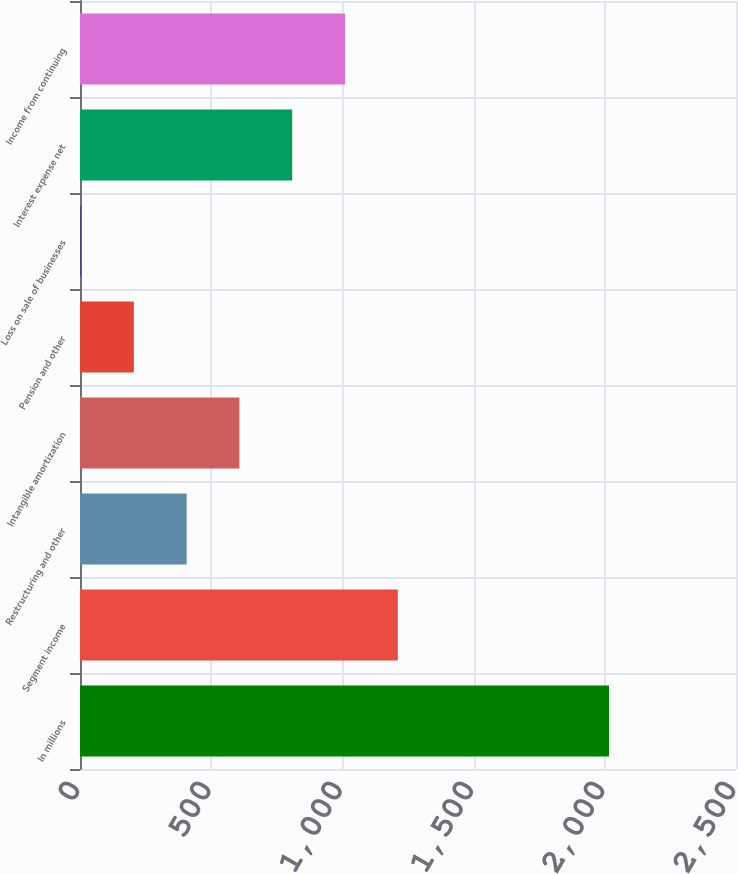Convert chart to OTSL. <chart><loc_0><loc_0><loc_500><loc_500><bar_chart><fcel>In millions<fcel>Segment income<fcel>Restructuring and other<fcel>Intangible amortization<fcel>Pension and other<fcel>Loss on sale of businesses<fcel>Interest expense net<fcel>Income from continuing<nl><fcel>2016<fcel>1211.16<fcel>406.32<fcel>607.53<fcel>205.11<fcel>3.9<fcel>808.74<fcel>1009.95<nl></chart> 